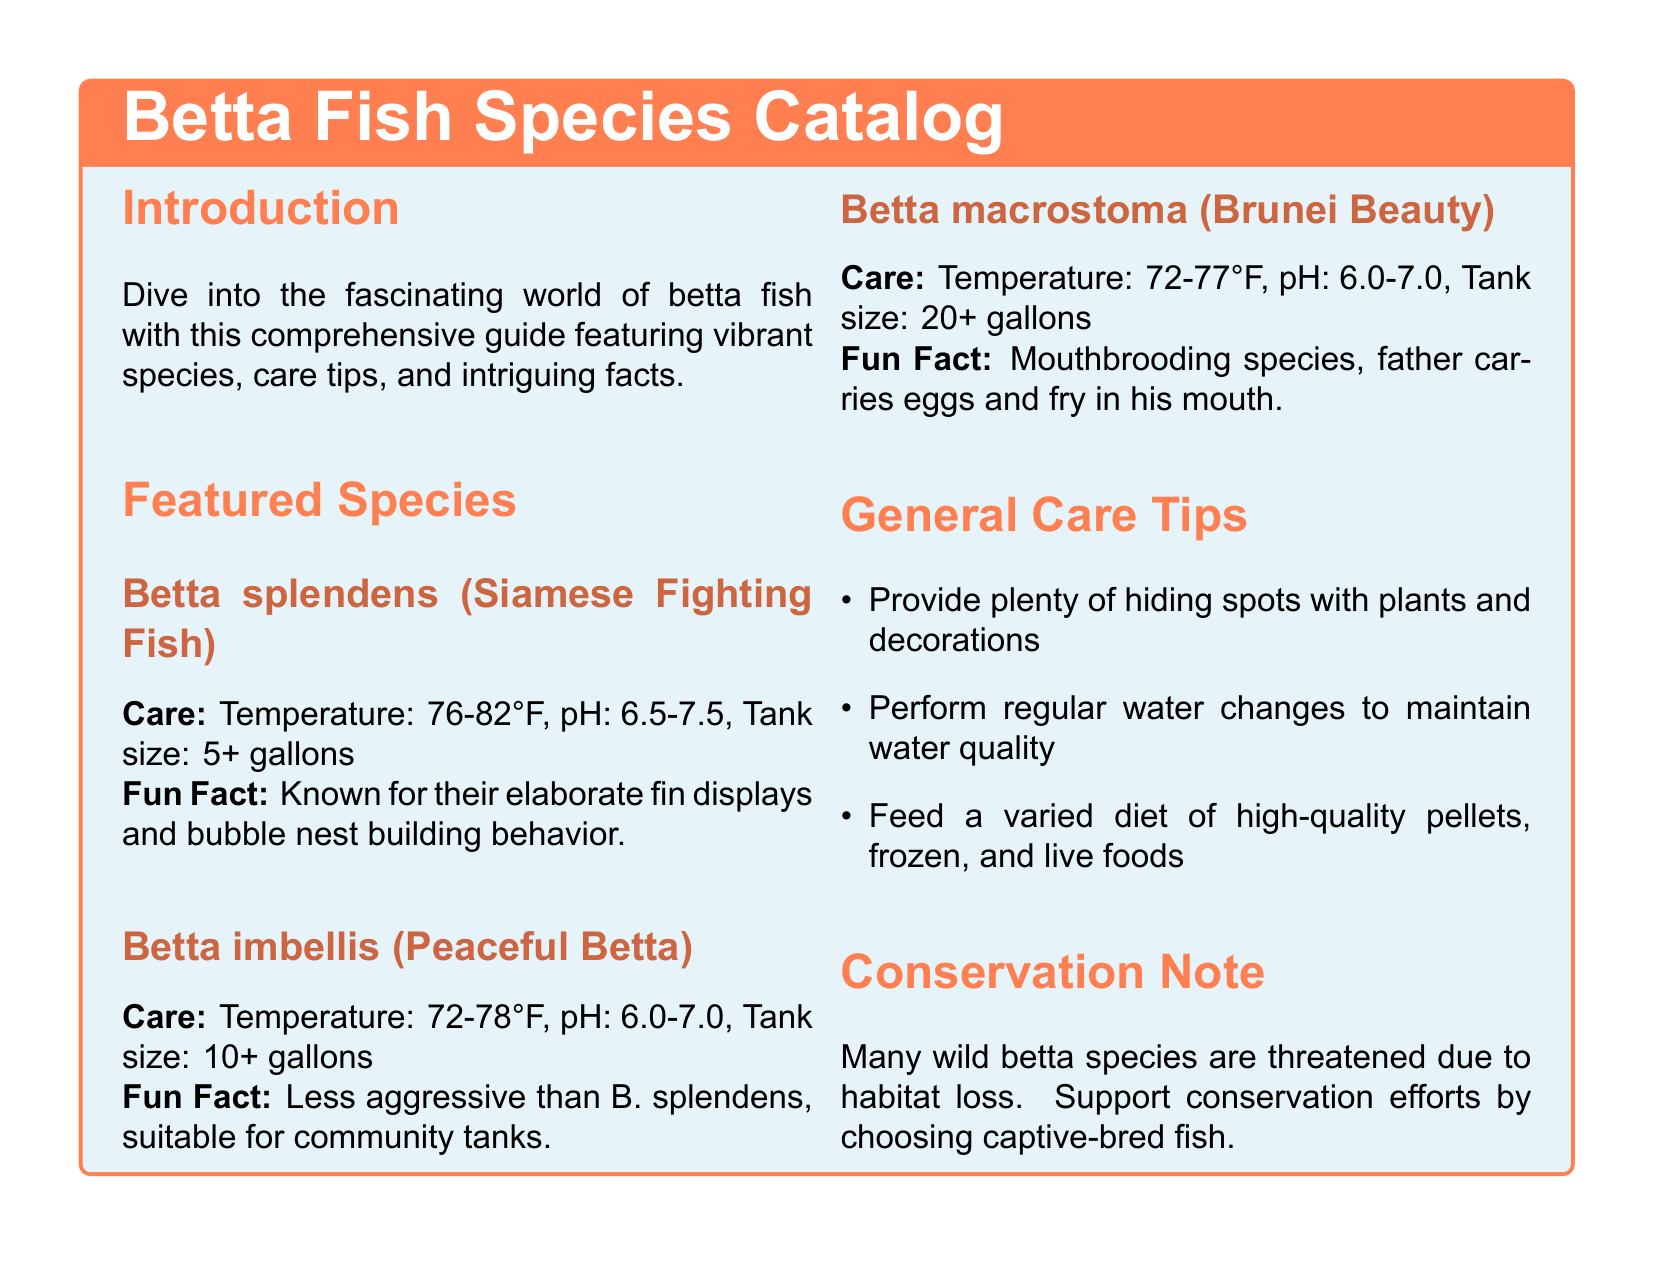What is the title of the document? The title is presented at the beginning of the document in a prominent box highlighting the catalog's purpose.
Answer: Betta Fish Species Catalog What is the care temperature range for Betta splendens? The temperature range is specified under the care requirements for Betta splendens.
Answer: 76-82°F Which betta species is known for mouthbrooding? The document includes a fun fact about mouthbrooding, specifically about one betta species.
Answer: Betta macrostoma What is the minimum tank size recommended for Betta imbellis? Tank size requirements are provided for each species, particularly for Betta imbellis.
Answer: 10+ gallons What type of environment is suggested for betta fish care? The document lists care tips that include environmental conditions for betta fish.
Answer: Hiding spots with plants and decorations How does Betta imbellis compare in aggression to Betta splendens? The document provides a comparative fun fact about the behavior of the two species.
Answer: Less aggressive What is a critical conservation note mentioned in the document? The document includes a specific note regarding the conservation status of wild bettas.
Answer: Habitat loss What type of foods should be included in a betta's diet? The document outlines a varied diet in the general care tips section for betta fish.
Answer: High-quality pellets, frozen, and live foods 